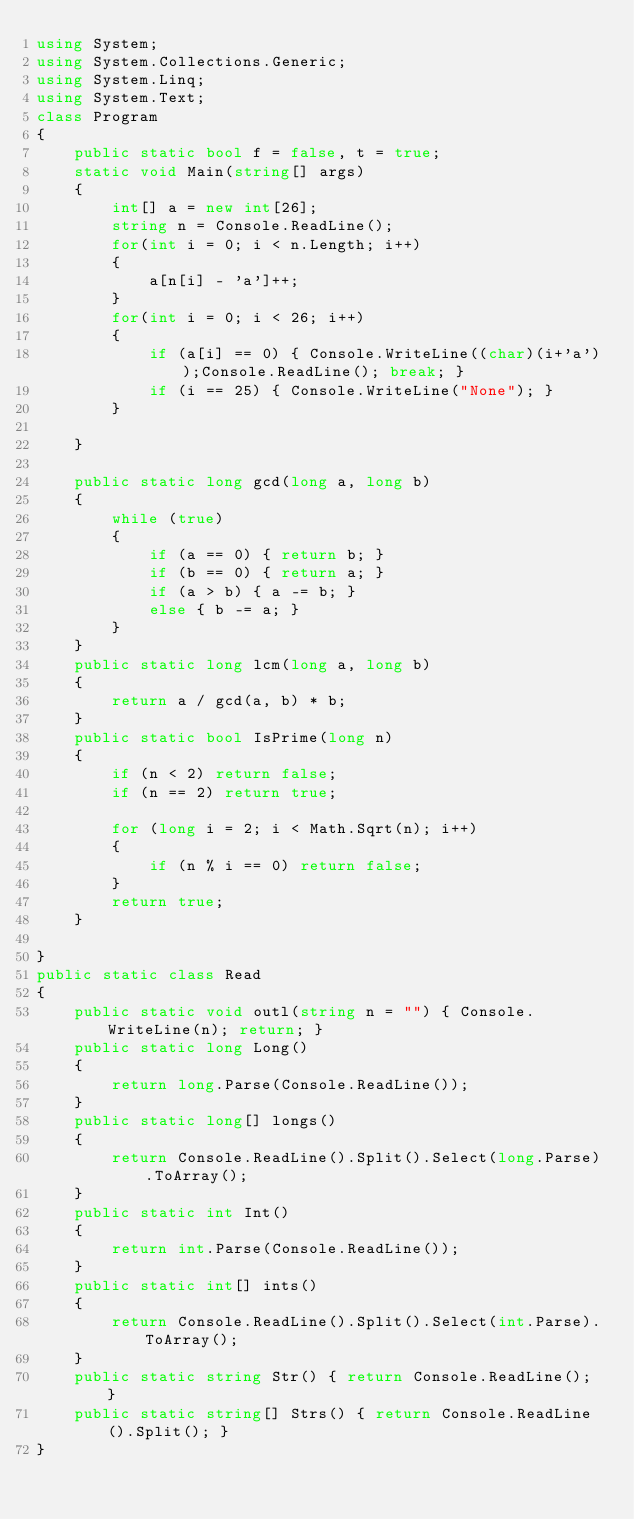<code> <loc_0><loc_0><loc_500><loc_500><_C#_>using System;
using System.Collections.Generic;
using System.Linq;
using System.Text;
class Program
{
    public static bool f = false, t = true;
    static void Main(string[] args)
    {
        int[] a = new int[26];
        string n = Console.ReadLine();
        for(int i = 0; i < n.Length; i++)
        {
            a[n[i] - 'a']++;
        }
        for(int i = 0; i < 26; i++)
        {
            if (a[i] == 0) { Console.WriteLine((char)(i+'a'));Console.ReadLine(); break; }
            if (i == 25) { Console.WriteLine("None"); }
        }
        
    }

    public static long gcd(long a, long b)
    {
        while (true)
        {
            if (a == 0) { return b; }
            if (b == 0) { return a; }
            if (a > b) { a -= b; }
            else { b -= a; }
        }
    }
    public static long lcm(long a, long b)
    {
        return a / gcd(a, b) * b;
    }
    public static bool IsPrime(long n)
    {
        if (n < 2) return false;
        if (n == 2) return true;

        for (long i = 2; i < Math.Sqrt(n); i++)
        {
            if (n % i == 0) return false;
        }
        return true;
    }

}
public static class Read
{
    public static void outl(string n = "") { Console.WriteLine(n); return; }
    public static long Long()
    {
        return long.Parse(Console.ReadLine());
    }
    public static long[] longs()
    {
        return Console.ReadLine().Split().Select(long.Parse).ToArray();
    }
    public static int Int()
    {
        return int.Parse(Console.ReadLine());
    }
    public static int[] ints()
    {
        return Console.ReadLine().Split().Select(int.Parse).ToArray();
    }
    public static string Str() { return Console.ReadLine(); }
    public static string[] Strs() { return Console.ReadLine().Split(); }
}</code> 